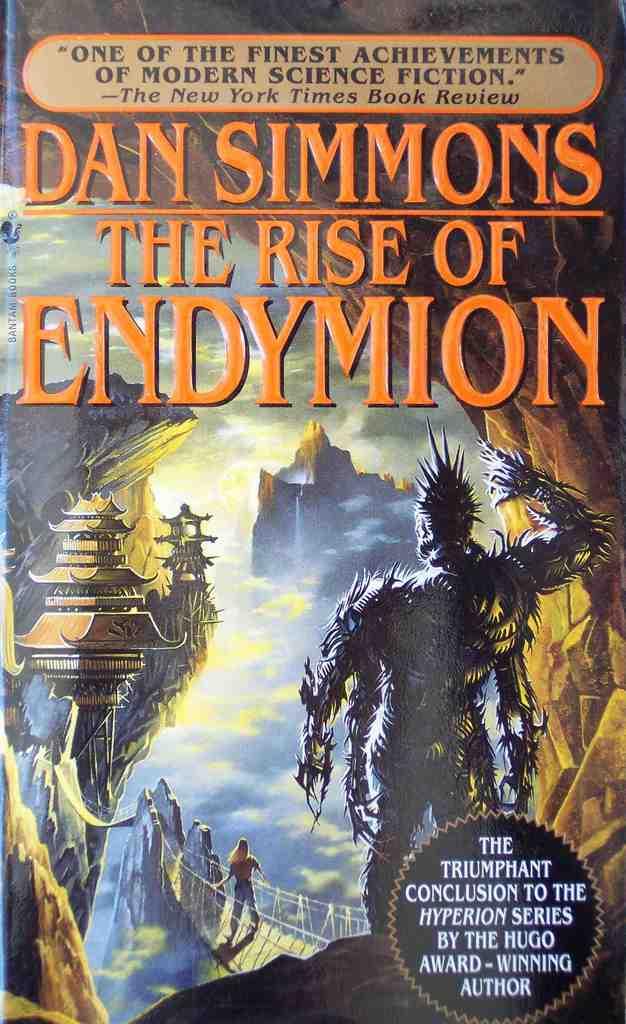What famous newspaper is quoted on this book cover?
Your response must be concise. The new york times. Who wrote this book?
Provide a short and direct response. Dan simmons. 